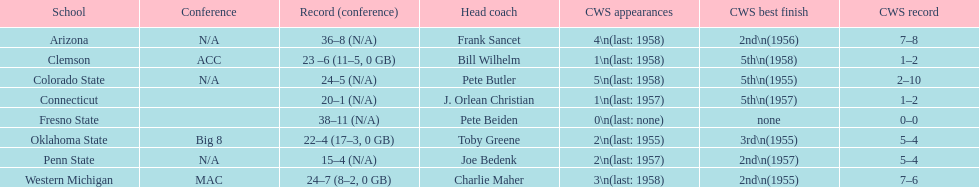Identify the schools that have been runners-up in the cws best finish standings. Arizona, Penn State, Western Michigan. 